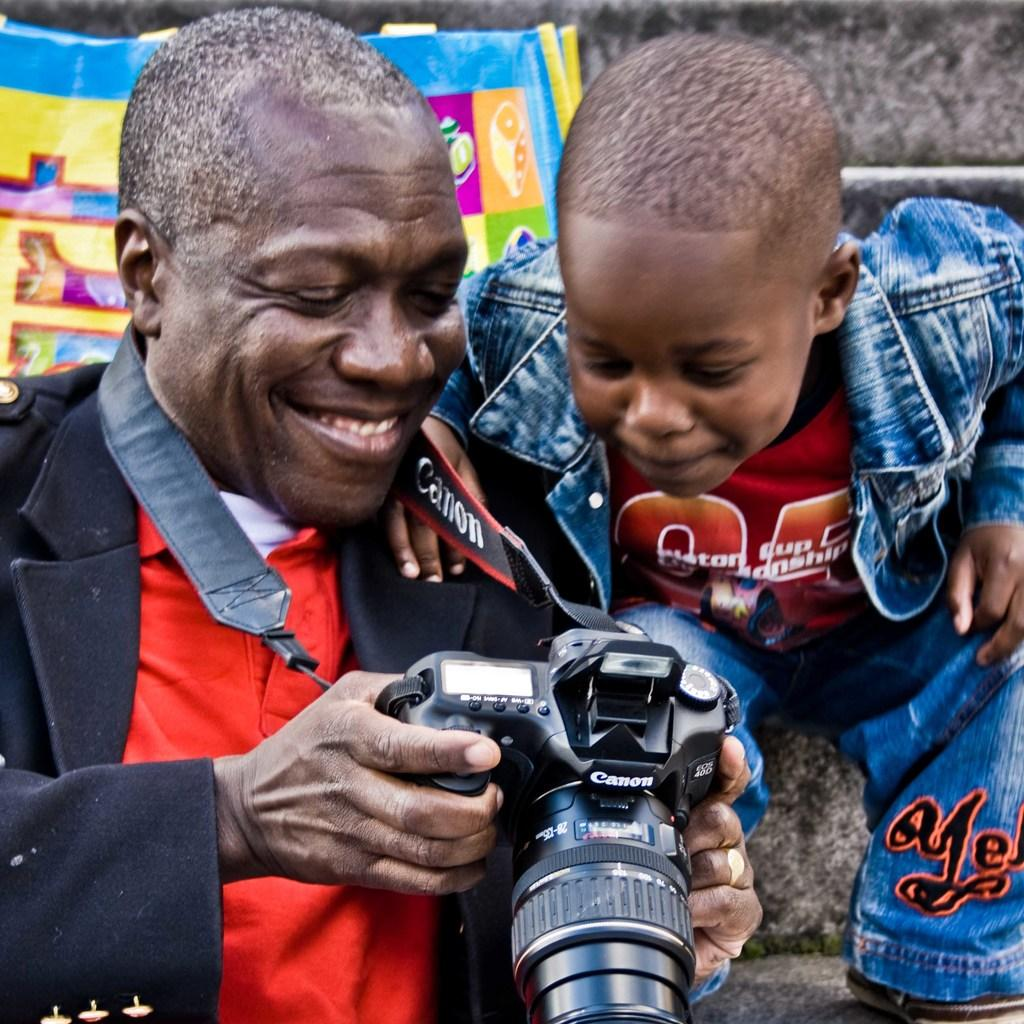Who is present in the image? There is a man and a boy in the image. What are the man and the boy wearing? Both the man and the boy are wearing colorful dresses. Can you describe any additional elements in the image? There is a banner visible on the back side of the image. How much dirt is visible on the boy's shoes in the image? There is no information about the boy's shoes or any dirt on them in the provided facts. --- Facts: 1. There is a car in the image. 2. The car is parked on the street. 3. There are trees lining the street. 4. The sky is visible in the image. Absurd Topics: fish, ocean, waves Conversation: What is the main subject of the image? The main subject of the image is a car. Where is the car located? The car is parked on the street. What can be seen alongside the street? There are trees lining the street. What is visible in the background of the image? The sky is visible in the image. Reasoning: Let's think step by step in order to produce the conversation. We start by identifying the main subject of the image, which is the car. Then, we describe its location, noting that it is parked on the street. Next, we mention the presence of trees, which provide context about the setting. Finally, we acknowledge the presence of the sky, which is visible in the background. Absurd Question/Answer: How many fish can be seen swimming in the ocean in the image? There is no ocean or fish present in the image; it features a car parked on the street with trees and the sky visible in the background. 